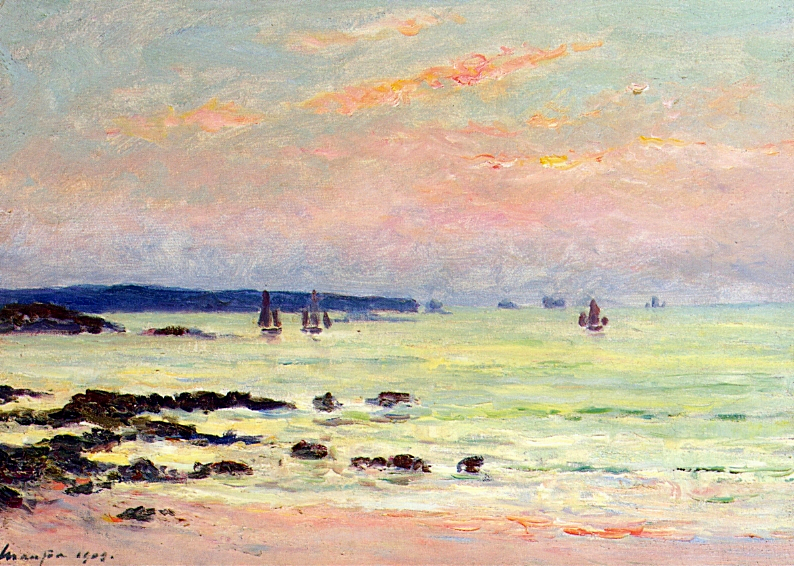What might be the historical or artistic context surrounding this painting? This painting was created during a pivotal era in art history, marked by the rise of the Impressionist movement in the late 19th century, primarily in France. Artists like Monet sought to break away from the traditional approaches of painting, focusing instead on natural light, shade, and color. Impressionists often painted en plein air (outdoors) to capture their immediate impressions of the scene, prioritizing spontaneity and sensory perception over detail. This painting not only reflects Monet's mastery of this technique but also his interest in capturing maritime and coastal sceneries, which is a recurring theme in his work. It illustrates the historical shift towards modernism in art, where the experience depicted becomes as important as the representation itself. 